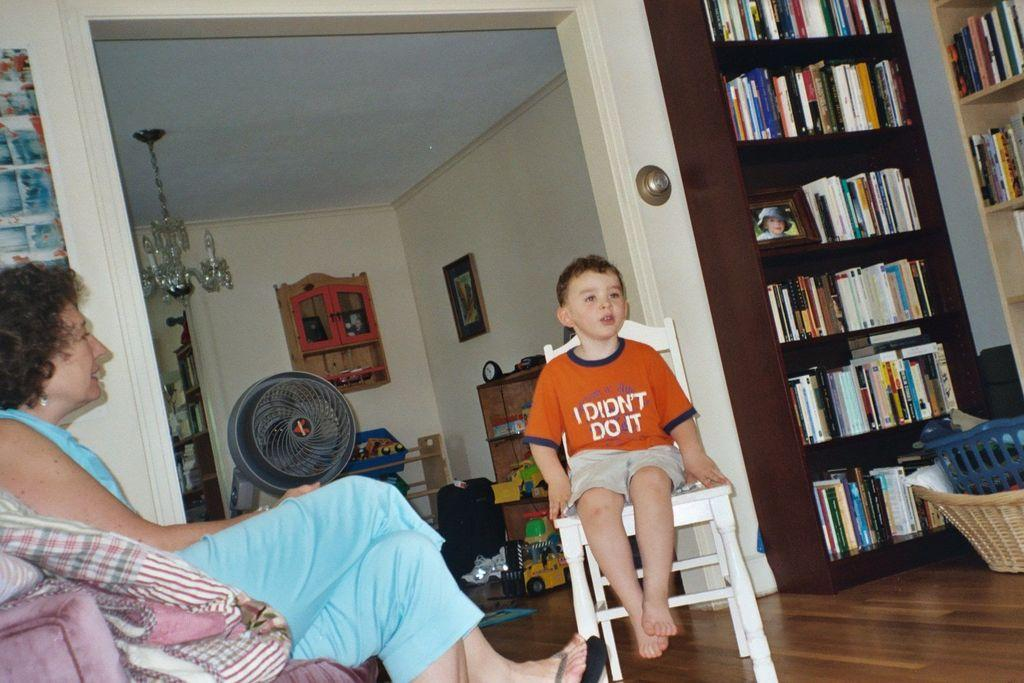Provide a one-sentence caption for the provided image. A woman and a child wearing a shirt that says I didn't do it. 